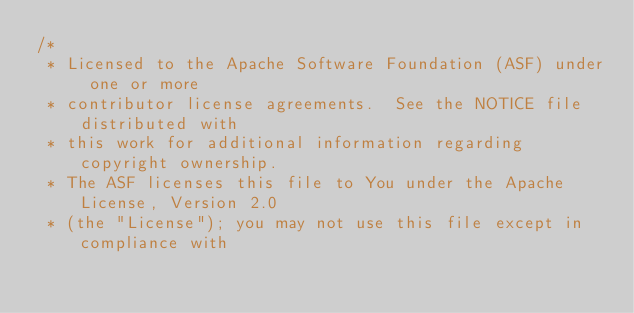Convert code to text. <code><loc_0><loc_0><loc_500><loc_500><_Java_>/*
 * Licensed to the Apache Software Foundation (ASF) under one or more
 * contributor license agreements.  See the NOTICE file distributed with
 * this work for additional information regarding copyright ownership.
 * The ASF licenses this file to You under the Apache License, Version 2.0
 * (the "License"); you may not use this file except in compliance with</code> 